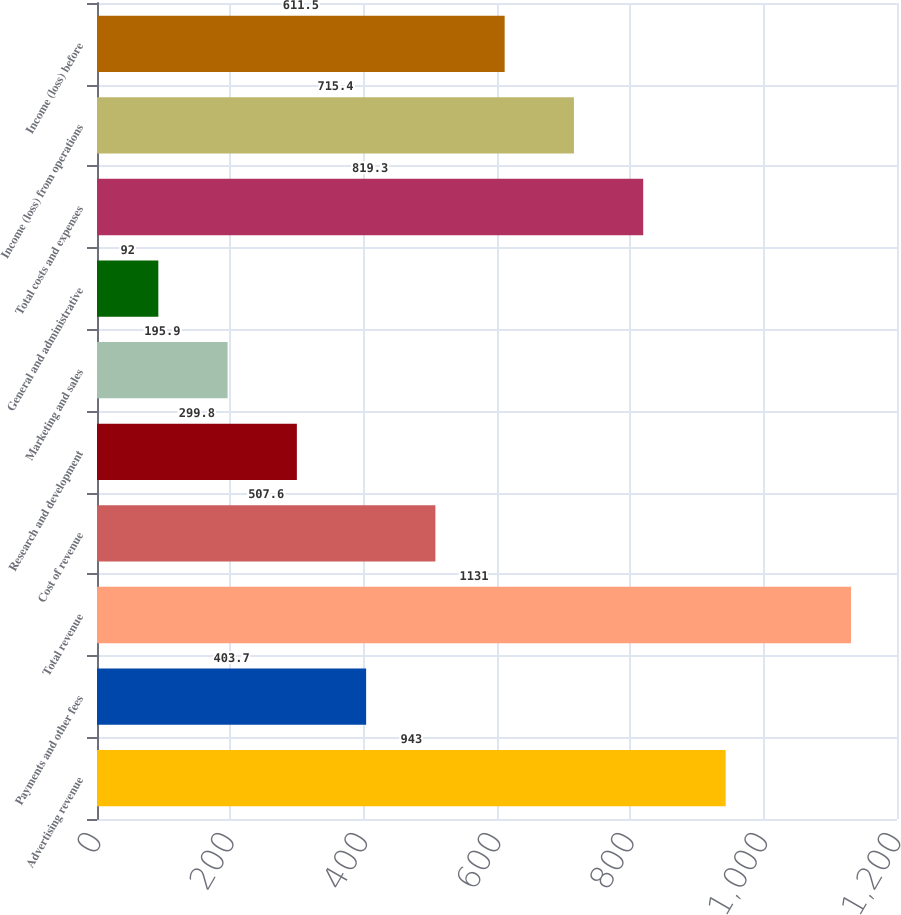<chart> <loc_0><loc_0><loc_500><loc_500><bar_chart><fcel>Advertising revenue<fcel>Payments and other fees<fcel>Total revenue<fcel>Cost of revenue<fcel>Research and development<fcel>Marketing and sales<fcel>General and administrative<fcel>Total costs and expenses<fcel>Income (loss) from operations<fcel>Income (loss) before<nl><fcel>943<fcel>403.7<fcel>1131<fcel>507.6<fcel>299.8<fcel>195.9<fcel>92<fcel>819.3<fcel>715.4<fcel>611.5<nl></chart> 